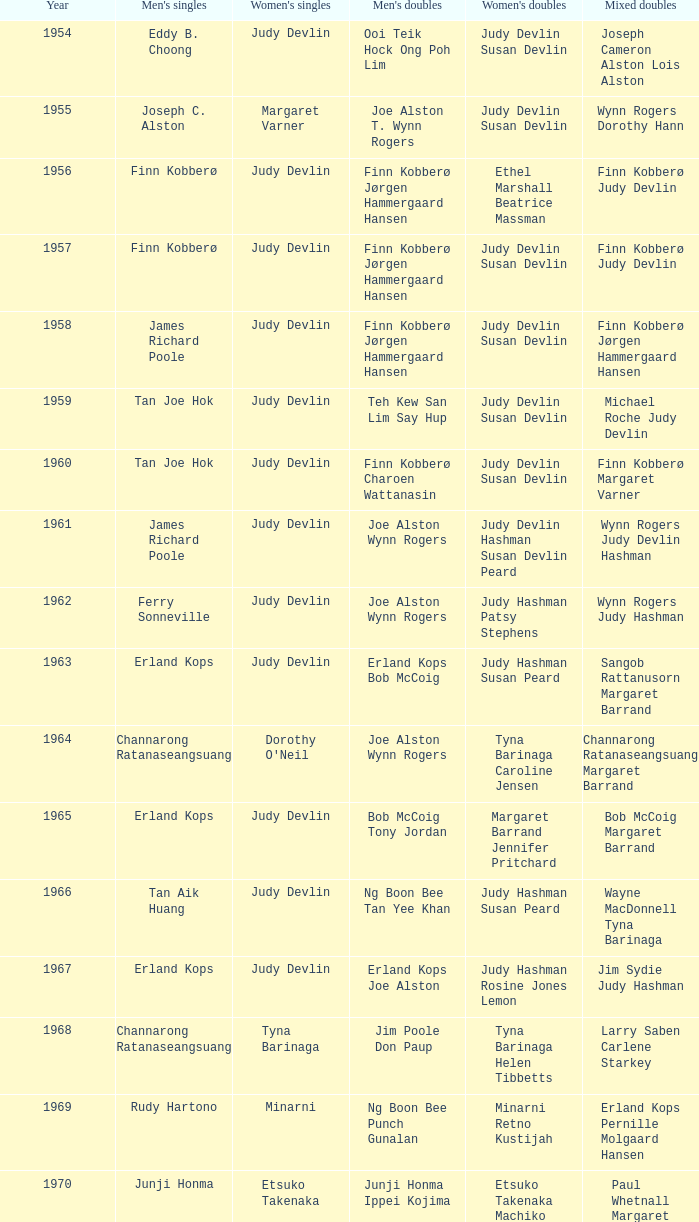Who were the men's doubles champions when the men's singles champion was muljadi? Ng Boon Bee Punch Gunalan. 